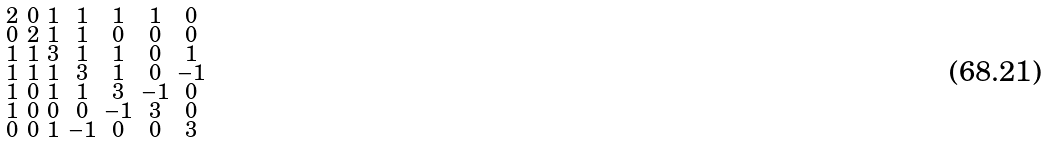<formula> <loc_0><loc_0><loc_500><loc_500>\begin{smallmatrix} 2 & 0 & 1 & 1 & 1 & 1 & 0 \\ 0 & 2 & 1 & 1 & 0 & 0 & 0 \\ 1 & 1 & 3 & 1 & 1 & 0 & 1 \\ 1 & 1 & 1 & 3 & 1 & 0 & - 1 \\ 1 & 0 & 1 & 1 & 3 & - 1 & 0 \\ 1 & 0 & 0 & 0 & - 1 & 3 & 0 \\ 0 & 0 & 1 & - 1 & 0 & 0 & 3 \end{smallmatrix}</formula> 